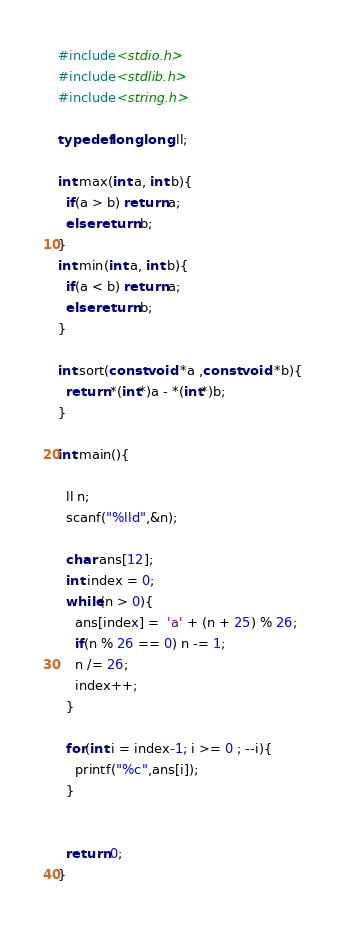Convert code to text. <code><loc_0><loc_0><loc_500><loc_500><_C_>#include<stdio.h>
#include<stdlib.h>
#include<string.h>

typedef long long ll;

int max(int a, int b){
  if(a > b) return a;
  else return b;
}
int min(int a, int b){
  if(a < b) return a;
  else return b;
}

int sort(const void *a ,const void *b){
  return *(int*)a - *(int*)b;
}

int main(){

  ll n;
  scanf("%lld",&n);

  char ans[12];
  int index = 0;
  while(n > 0){
    ans[index] =  'a' + (n + 25) % 26;
    if(n % 26 == 0) n -= 1;
    n /= 26;
    index++;
  }

  for(int i = index-1; i >= 0 ; --i){
    printf("%c",ans[i]);
  }


  return 0;
}
</code> 